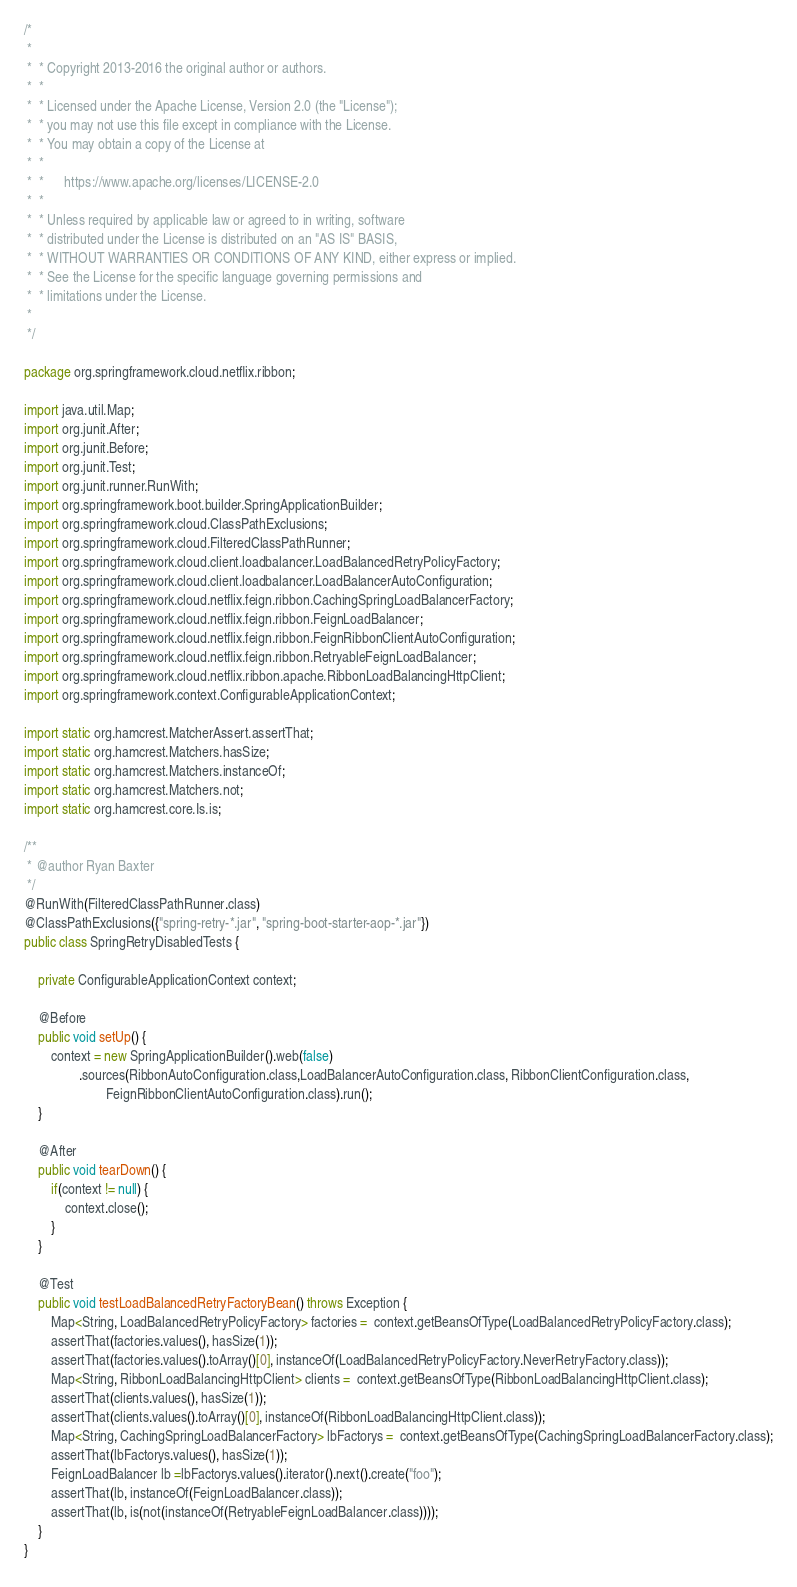Convert code to text. <code><loc_0><loc_0><loc_500><loc_500><_Java_>/*
 *
 *  * Copyright 2013-2016 the original author or authors.
 *  *
 *  * Licensed under the Apache License, Version 2.0 (the "License");
 *  * you may not use this file except in compliance with the License.
 *  * You may obtain a copy of the License at
 *  *
 *  *      https://www.apache.org/licenses/LICENSE-2.0
 *  *
 *  * Unless required by applicable law or agreed to in writing, software
 *  * distributed under the License is distributed on an "AS IS" BASIS,
 *  * WITHOUT WARRANTIES OR CONDITIONS OF ANY KIND, either express or implied.
 *  * See the License for the specific language governing permissions and
 *  * limitations under the License.
 *
 */

package org.springframework.cloud.netflix.ribbon;

import java.util.Map;
import org.junit.After;
import org.junit.Before;
import org.junit.Test;
import org.junit.runner.RunWith;
import org.springframework.boot.builder.SpringApplicationBuilder;
import org.springframework.cloud.ClassPathExclusions;
import org.springframework.cloud.FilteredClassPathRunner;
import org.springframework.cloud.client.loadbalancer.LoadBalancedRetryPolicyFactory;
import org.springframework.cloud.client.loadbalancer.LoadBalancerAutoConfiguration;
import org.springframework.cloud.netflix.feign.ribbon.CachingSpringLoadBalancerFactory;
import org.springframework.cloud.netflix.feign.ribbon.FeignLoadBalancer;
import org.springframework.cloud.netflix.feign.ribbon.FeignRibbonClientAutoConfiguration;
import org.springframework.cloud.netflix.feign.ribbon.RetryableFeignLoadBalancer;
import org.springframework.cloud.netflix.ribbon.apache.RibbonLoadBalancingHttpClient;
import org.springframework.context.ConfigurableApplicationContext;

import static org.hamcrest.MatcherAssert.assertThat;
import static org.hamcrest.Matchers.hasSize;
import static org.hamcrest.Matchers.instanceOf;
import static org.hamcrest.Matchers.not;
import static org.hamcrest.core.Is.is;

/**
 * @author Ryan Baxter
 */
@RunWith(FilteredClassPathRunner.class)
@ClassPathExclusions({"spring-retry-*.jar", "spring-boot-starter-aop-*.jar"})
public class SpringRetryDisabledTests {

	private ConfigurableApplicationContext context;

	@Before
	public void setUp() {
		context = new SpringApplicationBuilder().web(false)
				.sources(RibbonAutoConfiguration.class,LoadBalancerAutoConfiguration.class, RibbonClientConfiguration.class,
						FeignRibbonClientAutoConfiguration.class).run();
	}

	@After
	public void tearDown() {
		if(context != null) {
			context.close();
		}
	}

	@Test
	public void testLoadBalancedRetryFactoryBean() throws Exception {
		Map<String, LoadBalancedRetryPolicyFactory> factories =  context.getBeansOfType(LoadBalancedRetryPolicyFactory.class);
		assertThat(factories.values(), hasSize(1));
		assertThat(factories.values().toArray()[0], instanceOf(LoadBalancedRetryPolicyFactory.NeverRetryFactory.class));
		Map<String, RibbonLoadBalancingHttpClient> clients =  context.getBeansOfType(RibbonLoadBalancingHttpClient.class);
		assertThat(clients.values(), hasSize(1));
		assertThat(clients.values().toArray()[0], instanceOf(RibbonLoadBalancingHttpClient.class));
		Map<String, CachingSpringLoadBalancerFactory> lbFactorys =  context.getBeansOfType(CachingSpringLoadBalancerFactory.class);
		assertThat(lbFactorys.values(), hasSize(1));
		FeignLoadBalancer lb =lbFactorys.values().iterator().next().create("foo");
		assertThat(lb, instanceOf(FeignLoadBalancer.class));
		assertThat(lb, is(not(instanceOf(RetryableFeignLoadBalancer.class))));
	}
}
</code> 